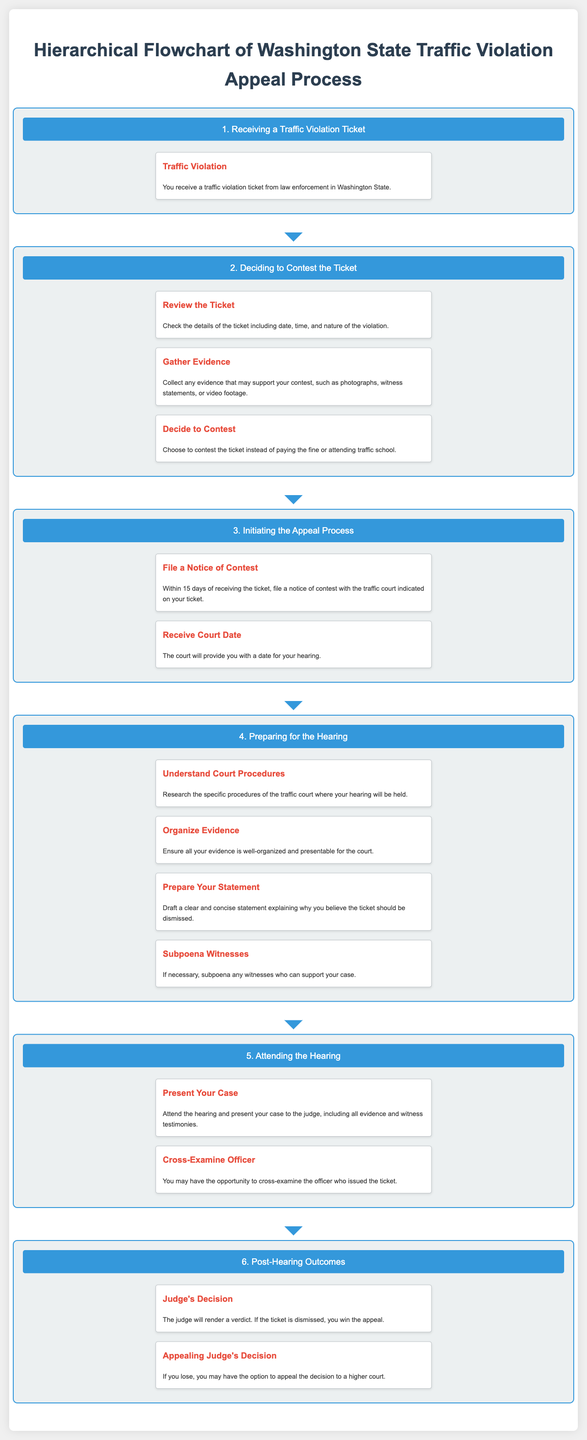What is the first step in the appeal process? The first step in the appeal process is outlined as "Receiving a Traffic Violation Ticket".
Answer: Receiving a Traffic Violation Ticket How many days do you have to file a notice of contest? The document states that you have "15 days" to file a notice of contest.
Answer: 15 days What should you collect to support your contest? The document mentions that you should collect "evidence" such as photographs, witness statements, or video footage.
Answer: Evidence What is one task included in preparing for the hearing? The document lists "Understand Court Procedures" as a task in preparing for the hearing.
Answer: Understand Court Procedures What can you do if you lose the hearing? According to the document, if you lose, you may have the option to "appeal" the decision to a higher court.
Answer: Appeal What does the judge do at the end of the hearing? The judge will "render a verdict" at the end of the hearing.
Answer: Render a verdict Which step involves presenting your evidence? The step that involves presenting your evidence is "Attending the Hearing".
Answer: Attending the Hearing What do you need to do after receiving your court date? After receiving your court date, you should "prepare for the hearing".
Answer: Prepare for the hearing 